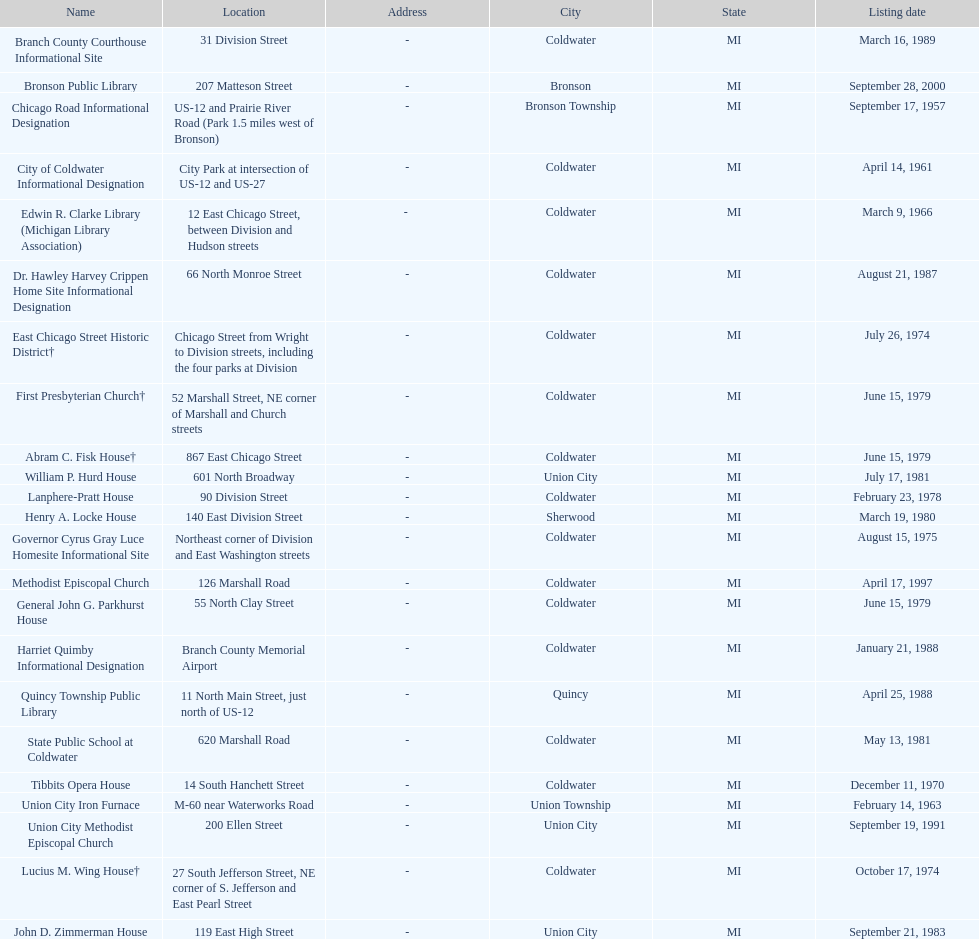What is the total current listing of names on this chart? 23. 